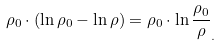Convert formula to latex. <formula><loc_0><loc_0><loc_500><loc_500>\rho _ { 0 } \cdot \left ( \ln { \rho _ { 0 } } - \ln \rho \right ) = \rho _ { 0 } \cdot \ln \frac { \rho _ { 0 } } \rho _ { . }</formula> 